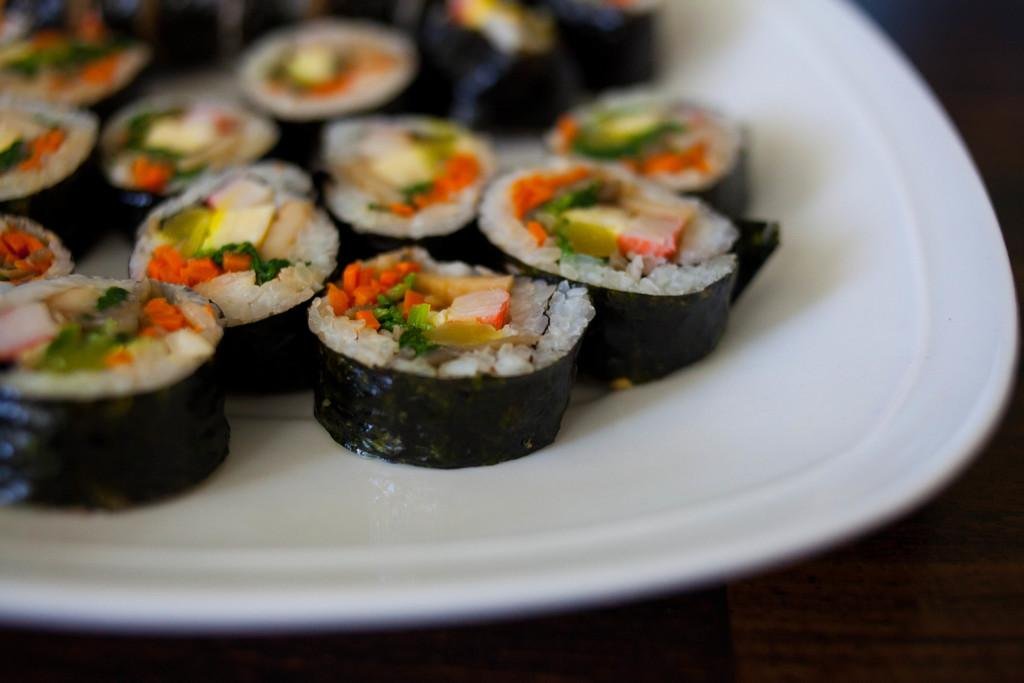What is on the plate that is visible in the image? There is food on a plate in the image. What is the color of the plate? The plate is white. What is the size of the island in the image? There is no island present in the image. How many fowls can be seen on the plate in the image? There is no fowl present on the plate in the image. 